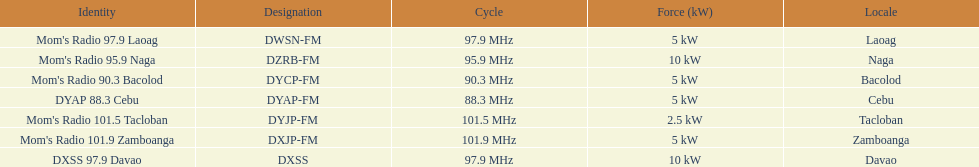Could you parse the entire table as a dict? {'header': ['Identity', 'Designation', 'Cycle', 'Force (kW)', 'Locale'], 'rows': [["Mom's Radio 97.9 Laoag", 'DWSN-FM', '97.9\xa0MHz', '5\xa0kW', 'Laoag'], ["Mom's Radio 95.9 Naga", 'DZRB-FM', '95.9\xa0MHz', '10\xa0kW', 'Naga'], ["Mom's Radio 90.3 Bacolod", 'DYCP-FM', '90.3\xa0MHz', '5\xa0kW', 'Bacolod'], ['DYAP 88.3 Cebu', 'DYAP-FM', '88.3\xa0MHz', '5\xa0kW', 'Cebu'], ["Mom's Radio 101.5 Tacloban", 'DYJP-FM', '101.5\xa0MHz', '2.5\xa0kW', 'Tacloban'], ["Mom's Radio 101.9 Zamboanga", 'DXJP-FM', '101.9\xa0MHz', '5\xa0kW', 'Zamboanga'], ['DXSS 97.9 Davao', 'DXSS', '97.9\xa0MHz', '10\xa0kW', 'Davao']]} What is the only radio station with a frequency below 90 mhz? DYAP 88.3 Cebu. 